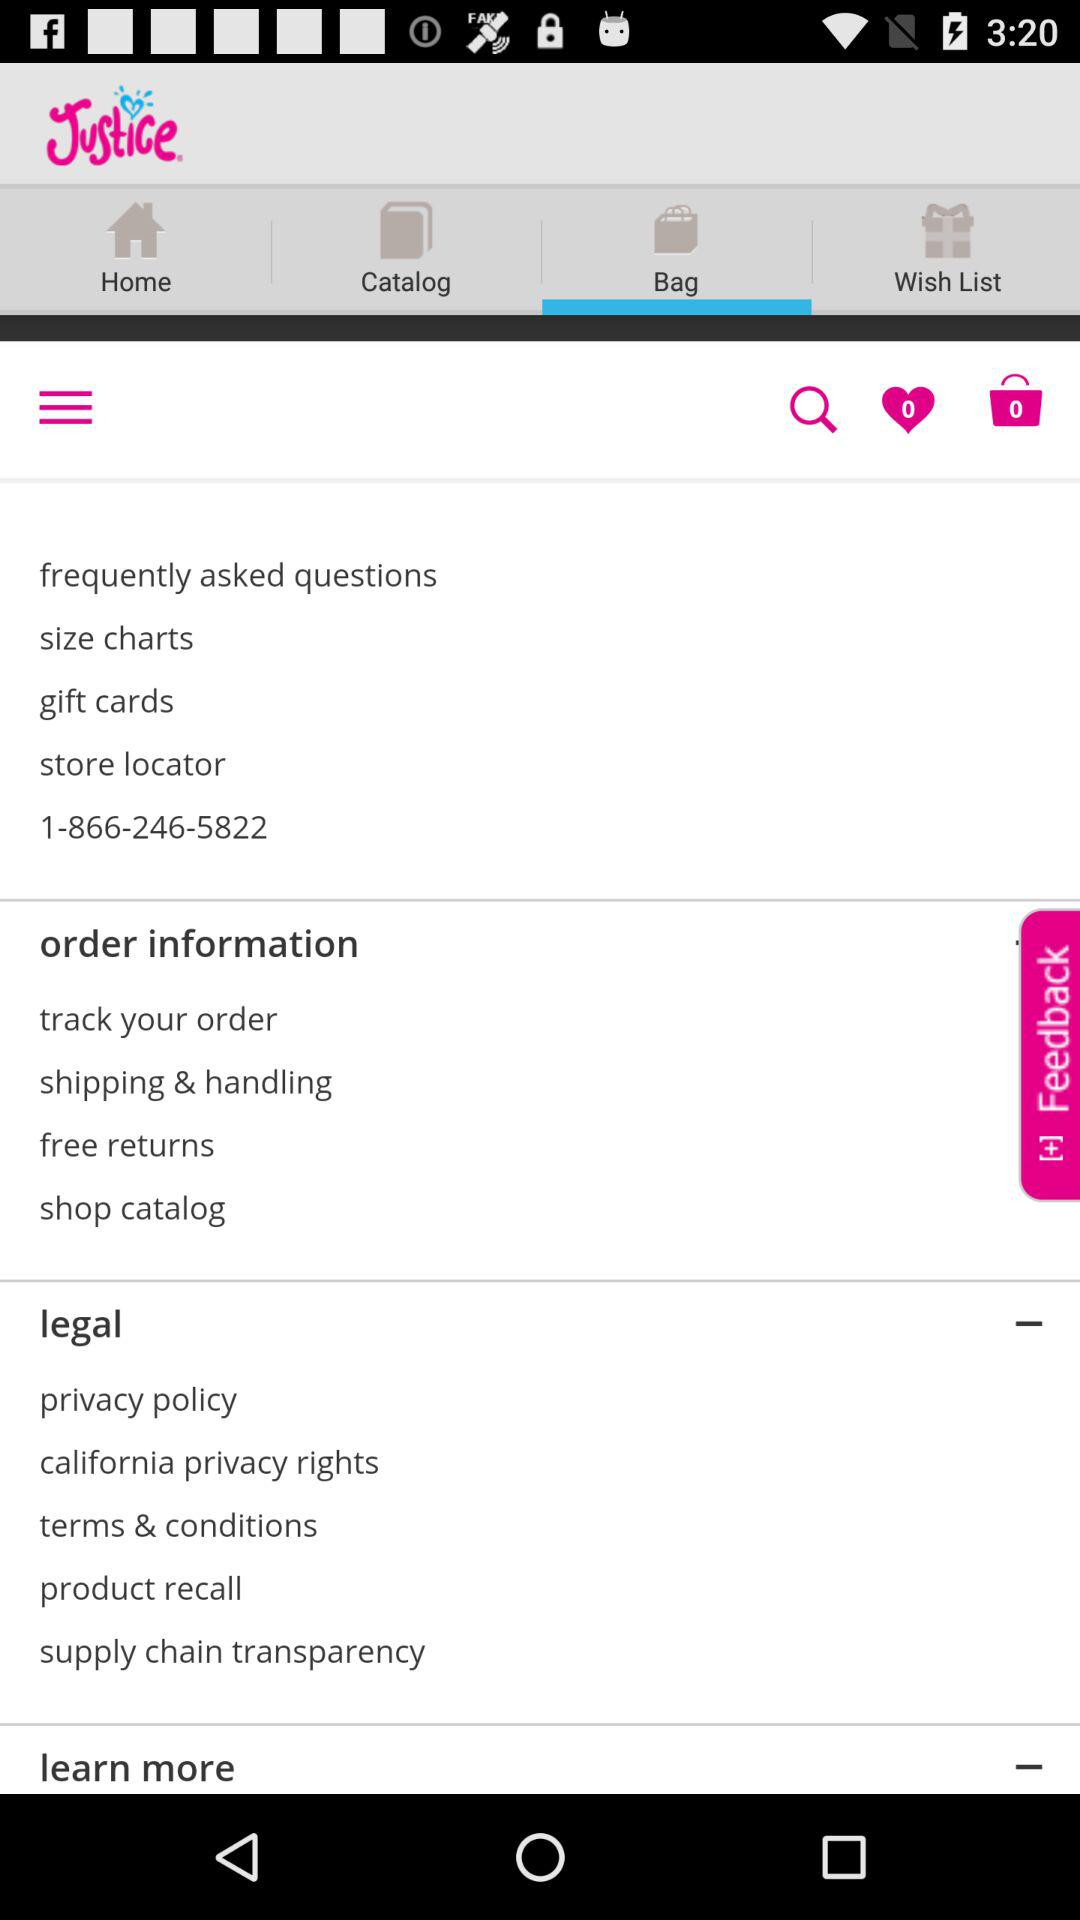What is the given phone number? The given phone number is 1-866-246-5822. 